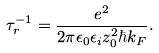<formula> <loc_0><loc_0><loc_500><loc_500>\tau _ { r } ^ { - 1 } = \frac { e ^ { 2 } } { 2 \pi \epsilon _ { 0 } \epsilon _ { i } z _ { 0 } ^ { 2 } \hbar { k } _ { F } } .</formula> 